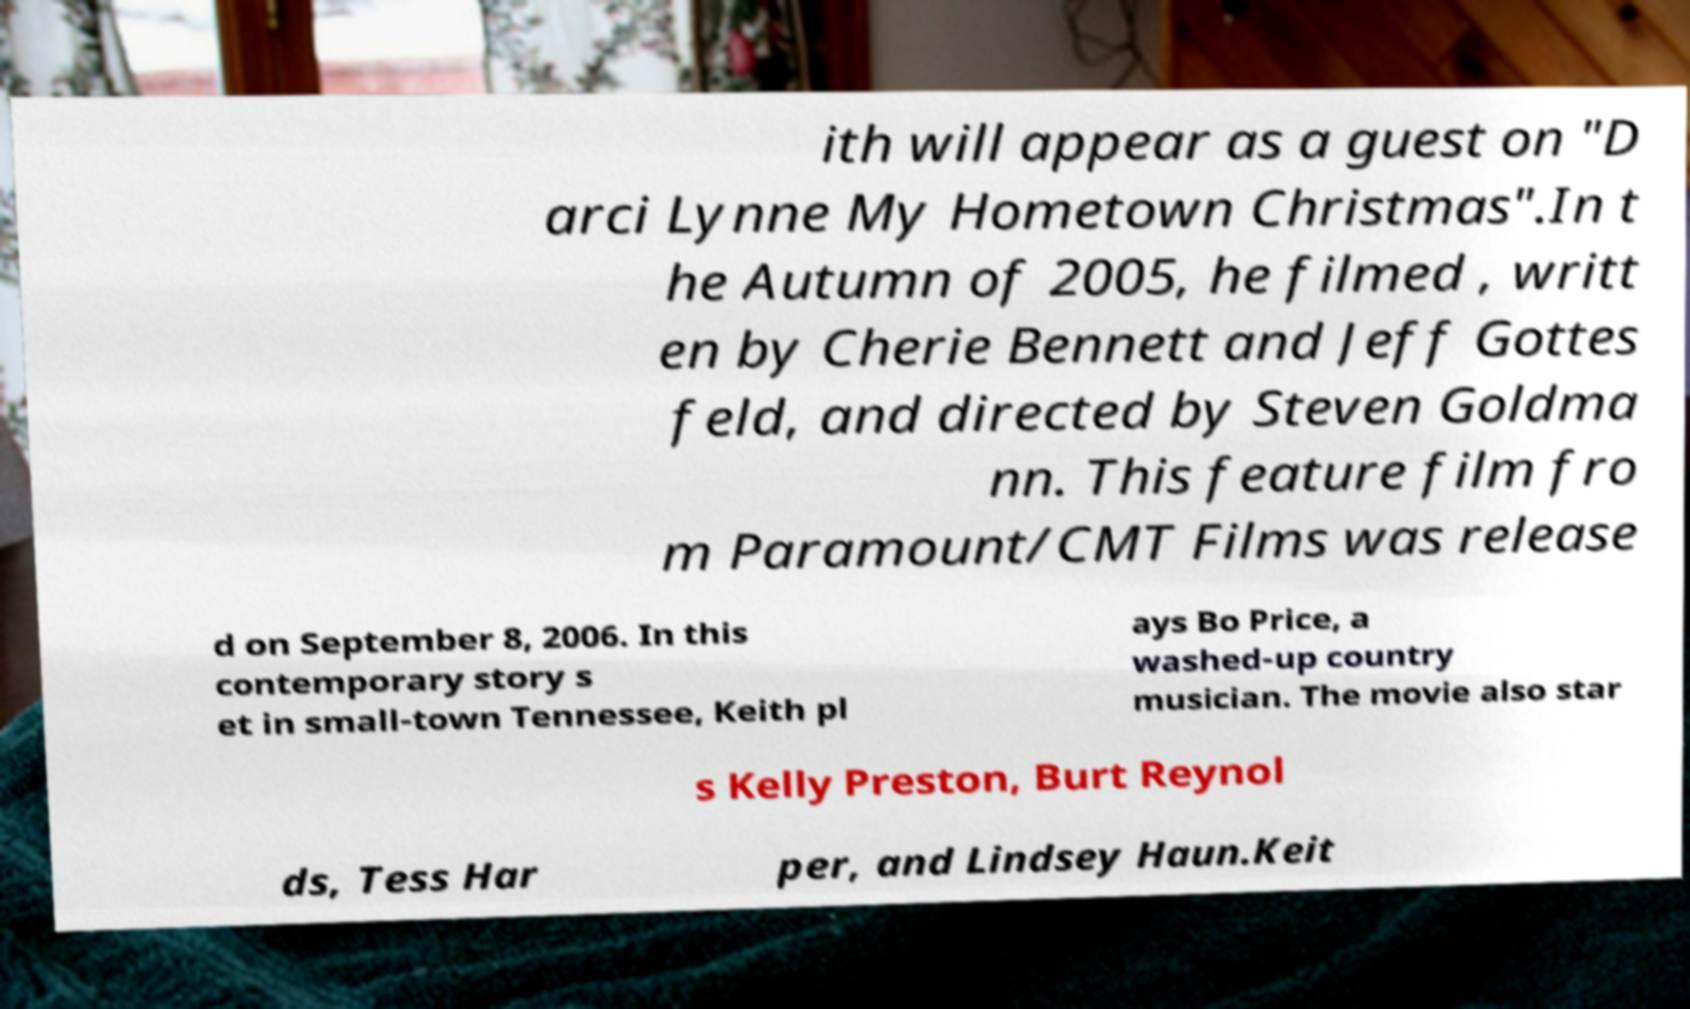Can you accurately transcribe the text from the provided image for me? ith will appear as a guest on "D arci Lynne My Hometown Christmas".In t he Autumn of 2005, he filmed , writt en by Cherie Bennett and Jeff Gottes feld, and directed by Steven Goldma nn. This feature film fro m Paramount/CMT Films was release d on September 8, 2006. In this contemporary story s et in small-town Tennessee, Keith pl ays Bo Price, a washed-up country musician. The movie also star s Kelly Preston, Burt Reynol ds, Tess Har per, and Lindsey Haun.Keit 